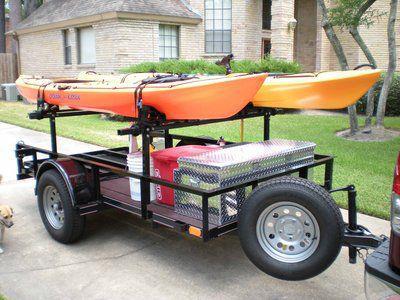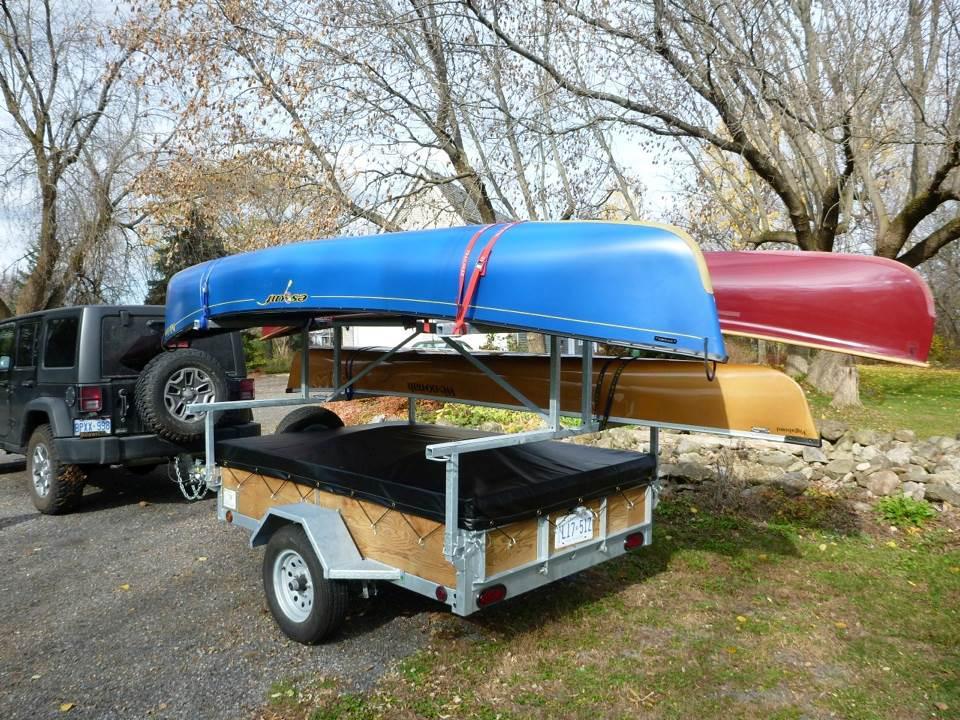The first image is the image on the left, the second image is the image on the right. For the images displayed, is the sentence "One trailer is loaded with at least one boat, while the other is loaded with at least one boat plus other riding vehicles." factually correct? Answer yes or no. No. The first image is the image on the left, the second image is the image on the right. Assess this claim about the two images: "Two canoes of the same color are on a trailer.". Correct or not? Answer yes or no. Yes. 